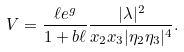Convert formula to latex. <formula><loc_0><loc_0><loc_500><loc_500>V = \frac { \ell e ^ { g } } { 1 + b \ell } \frac { | \lambda | ^ { 2 } } { x _ { 2 } x _ { 3 } | \eta _ { 2 } \eta _ { 3 } | ^ { 4 } } .</formula> 